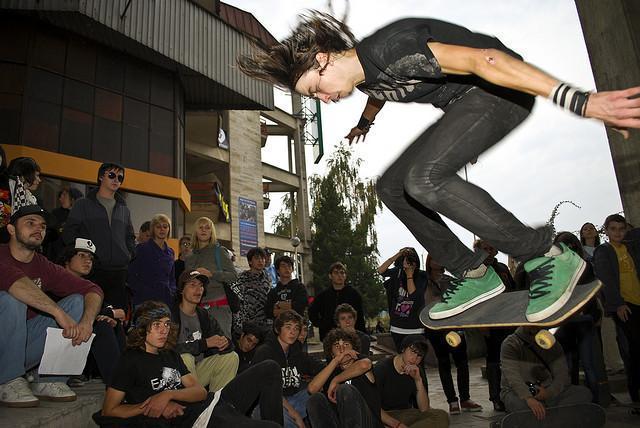How many people are visible?
Give a very brief answer. 11. How many clocks in the photo?
Give a very brief answer. 0. 